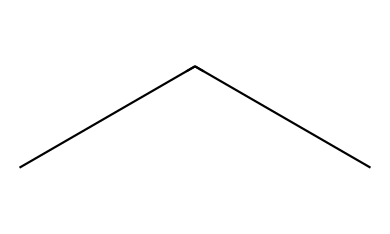What is the chemical name of this compound? The SMILES representation 'CCC' corresponds to a three-carbon chain, which is known as propane.
Answer: propane How many hydrogen atoms are present in this molecule? In propane (C3H8), for every carbon atom, there are enough hydrogen atoms to fully saturate it, resulting in a total of eight hydrogen atoms in the structure.
Answer: 8 What type of hydrocarbon is propane classified as? Propane has only single bonds between carbon atoms and is fully saturated with hydrogen, classifying it as an alkane.
Answer: alkane How many carbon atoms are in the structure of propane? The SMILES 'CCC' indicates three carbon atoms are connected in a chain, thus confirming the total count.
Answer: 3 Why is propane considered an eco-friendly refrigerant? Propane has a low global warming potential compared to traditional refrigerants, and it does not deplete the ozone layer, making it more environmentally friendly.
Answer: low global warming potential What phase is propane at room temperature? At room temperature, propane exists as a gas, but it can be condensed into a liquid under pressure; however, the question focuses on the usual state at normal room conditions.
Answer: gas What kind of bonds are present in propane? The structure of propane contains only single covalent bonds between the carbon and hydrogen atoms, indicating it is a saturated molecule.
Answer: single covalent bonds 